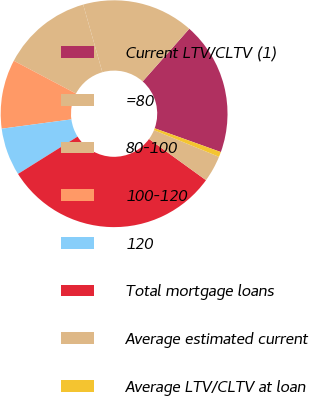<chart> <loc_0><loc_0><loc_500><loc_500><pie_chart><fcel>Current LTV/CLTV (1)<fcel>=80<fcel>80-100<fcel>100-120<fcel>120<fcel>Total mortgage loans<fcel>Average estimated current<fcel>Average LTV/CLTV at loan<nl><fcel>18.96%<fcel>15.92%<fcel>12.88%<fcel>9.84%<fcel>6.8%<fcel>31.12%<fcel>3.76%<fcel>0.72%<nl></chart> 